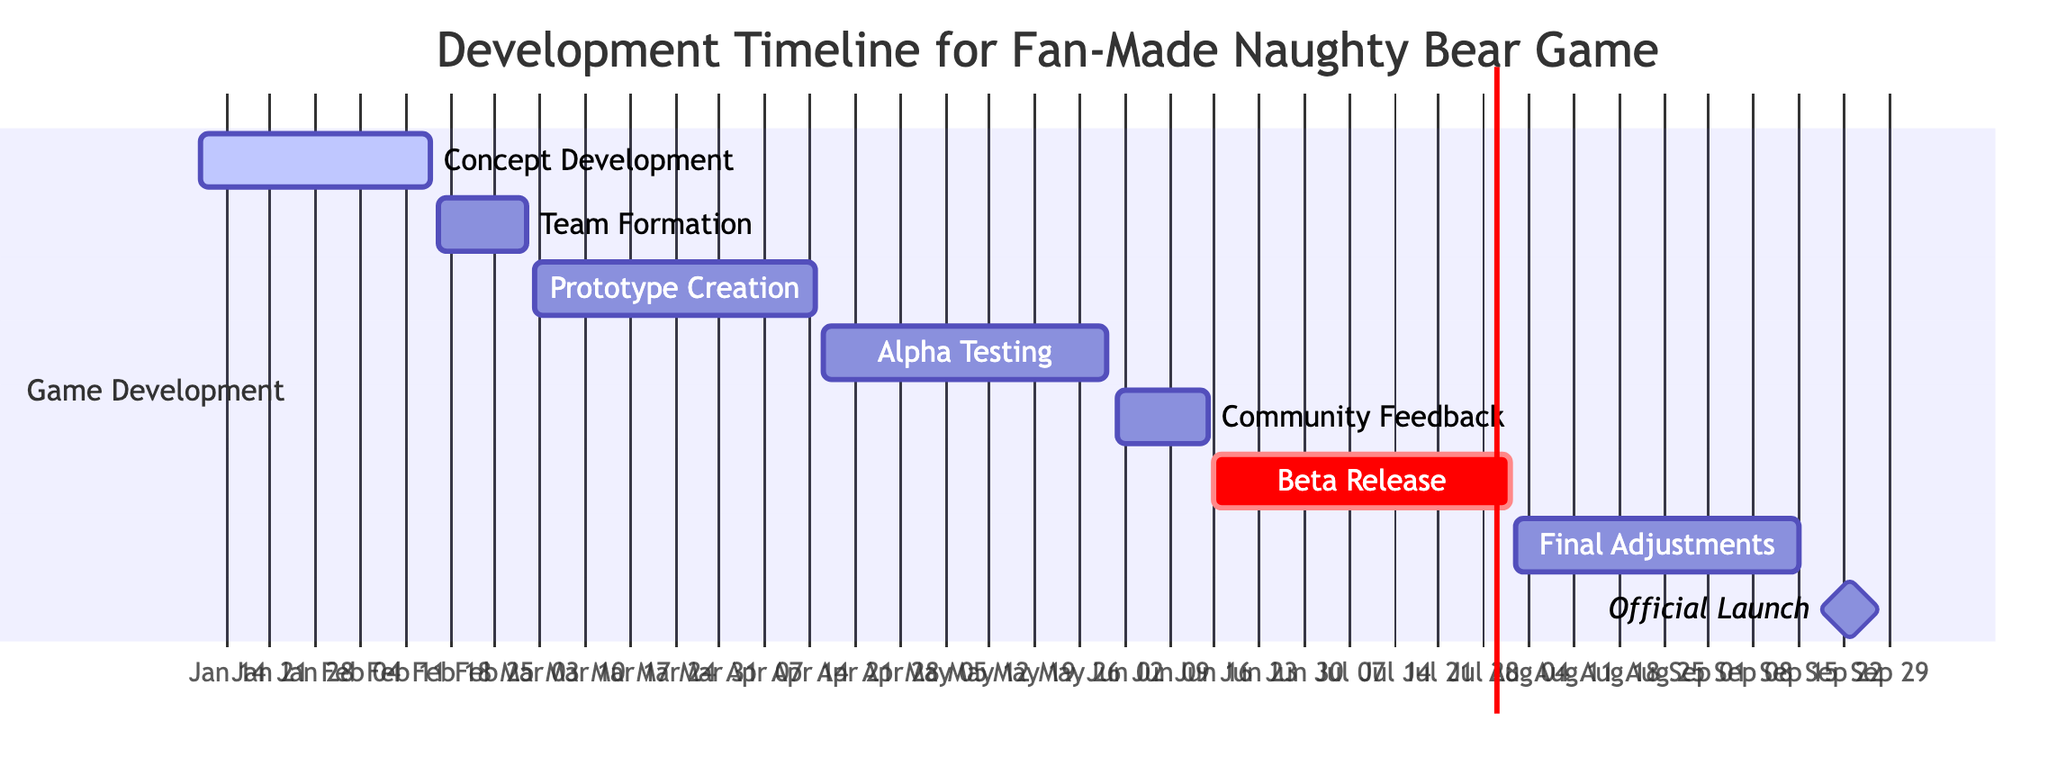What is the duration of the Prototype Creation task? To find the duration, subtract the start date from the end date. Prototype Creation starts on March 2, 2024, and ends on April 15, 2024. This results in a duration of 44 days.
Answer: 44 days Which task comes right before Beta Release? By looking at the Gantt chart timeline, the task directly preceding Beta Release is Final Adjustments, which runs from August 2, 2024, to September 15, 2024.
Answer: Final Adjustments How many milestones are there in total? Count the number of tasks listed in the Milestones section. There are eight tasks in total, each representing a crucial part of the development timeline.
Answer: 8 What is the start date of the Alpha Testing phase? The start date of Alpha Testing can be identified directly on the Gantt chart, which shows it starts on April 16, 2024.
Answer: April 16, 2024 How long is the time gap between Community Feedback and Beta Release? Community Feedback ends on June 15, 2024, and Beta Release starts on June 16, 2024. Thus, the gap between these two tasks is one day.
Answer: 1 day Which task has the longest duration? The duration of each task can be calculated by looking at their start and end dates. After comparing all the tasks, Alpha Testing is the longest, lasting from April 16, 2024, to May 30, 2024, totaling 44 days.
Answer: Alpha Testing What is the impact of the Beta Release being marked as critical? The designation of Beta Release as critical indicates that this phase is vital for the overall timeline, meaning that delays in this task could significantly affect the entire project schedule. Therefore, it's essential to monitor this phase closely.
Answer: Critical importance When does the Official Launch occur in the timeline? The Official Launch can be found on the Gantt chart, where it is clearly stated that it takes place from September 16, 2024, to September 30, 2024.
Answer: September 16, 2024 What task starts immediately after Team Formation ends? Team Formation ends on March 1, 2024, and the next task is Prototype Creation, which starts the very next day on March 2, 2024.
Answer: Prototype Creation 